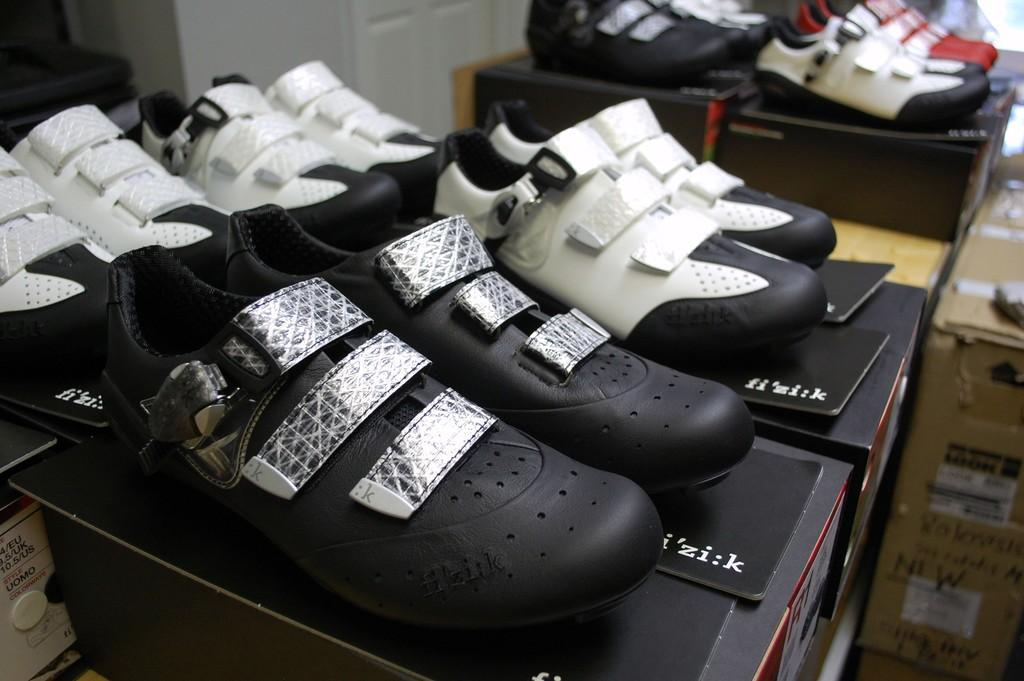What items are placed on boxes in the image? There are shoes on boxes in the image. Can you describe any other objects or features visible in the image? There are objects visible in the background of the image, but their specific details are not provided. What type of grass can be seen growing on the tail of the sail in the image? There is no grass, tail, or sail present in the image. 